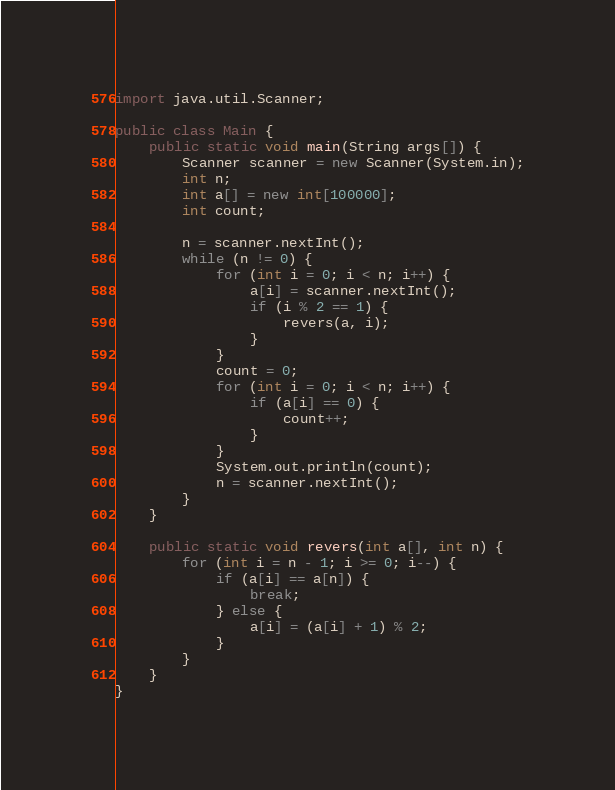<code> <loc_0><loc_0><loc_500><loc_500><_Java_>import java.util.Scanner;

public class Main {
	public static void main(String args[]) {
		Scanner scanner = new Scanner(System.in);
		int n;
		int a[] = new int[100000];
		int count;

		n = scanner.nextInt();
		while (n != 0) {
			for (int i = 0; i < n; i++) {
				a[i] = scanner.nextInt();
				if (i % 2 == 1) {
					revers(a, i);
				}
			}
			count = 0;
			for (int i = 0; i < n; i++) {
				if (a[i] == 0) {
					count++;
				}
			}
			System.out.println(count);
			n = scanner.nextInt();
		}
	}
	
	public static void revers(int a[], int n) {
		for (int i = n - 1; i >= 0; i--) {
			if (a[i] == a[n]) {
				break;
			} else {
				a[i] = (a[i] + 1) % 2;
			}
		}
	}
}</code> 